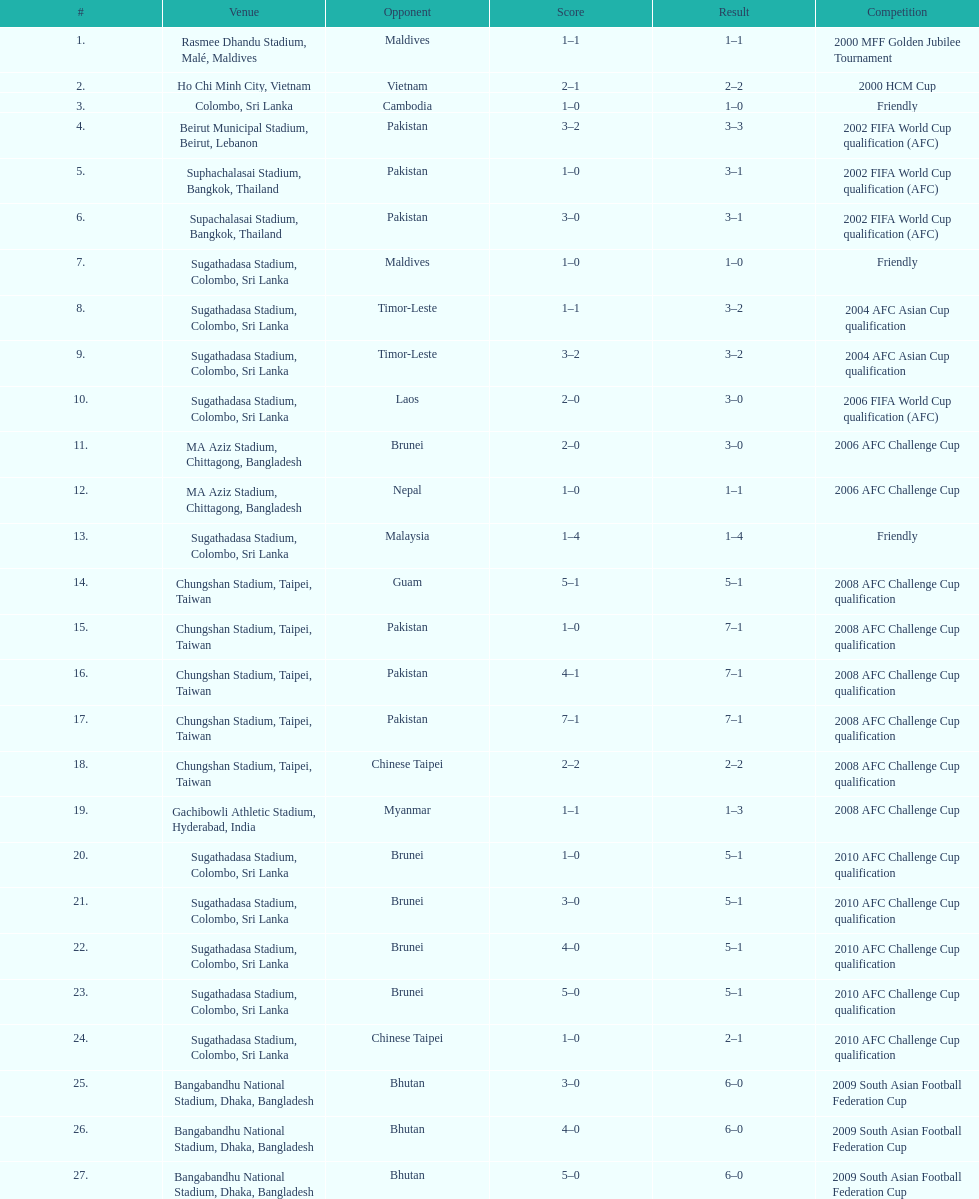What was the overall goal count in the sri lanka vs. malaysia match on march 24, 2007? 5. 